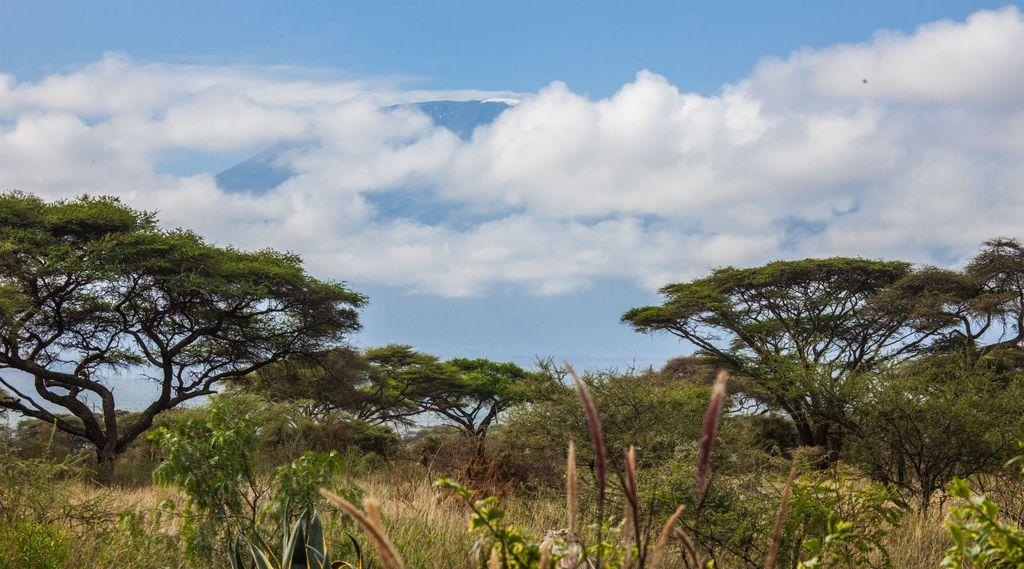What type of vegetation can be seen in the image? There are trees, plants, and grass in the image. What part of the natural environment is visible in the image? The sky is visible in the image. What can be seen in the sky? Clouds are present in the sky. What type of ring is your sister wearing in the image? There is no sister or ring present in the image; it features trees, plants, grass, and a sky with clouds. 